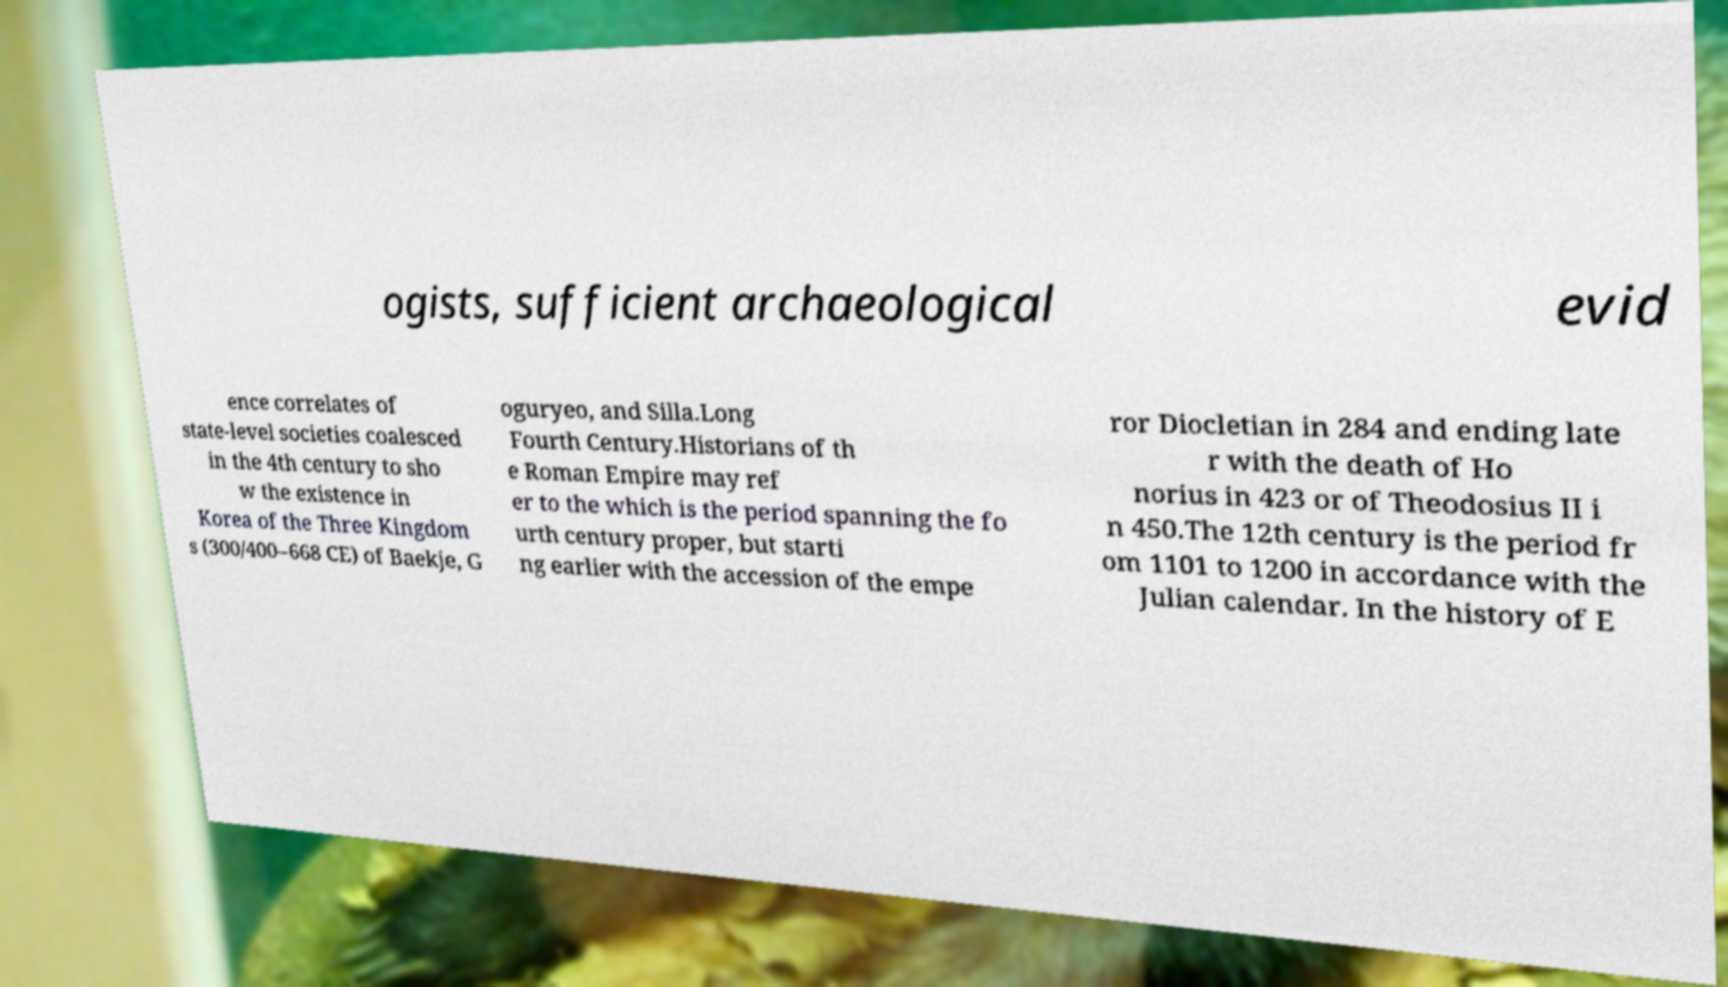What messages or text are displayed in this image? I need them in a readable, typed format. ogists, sufficient archaeological evid ence correlates of state-level societies coalesced in the 4th century to sho w the existence in Korea of the Three Kingdom s (300/400–668 CE) of Baekje, G oguryeo, and Silla.Long Fourth Century.Historians of th e Roman Empire may ref er to the which is the period spanning the fo urth century proper, but starti ng earlier with the accession of the empe ror Diocletian in 284 and ending late r with the death of Ho norius in 423 or of Theodosius II i n 450.The 12th century is the period fr om 1101 to 1200 in accordance with the Julian calendar. In the history of E 